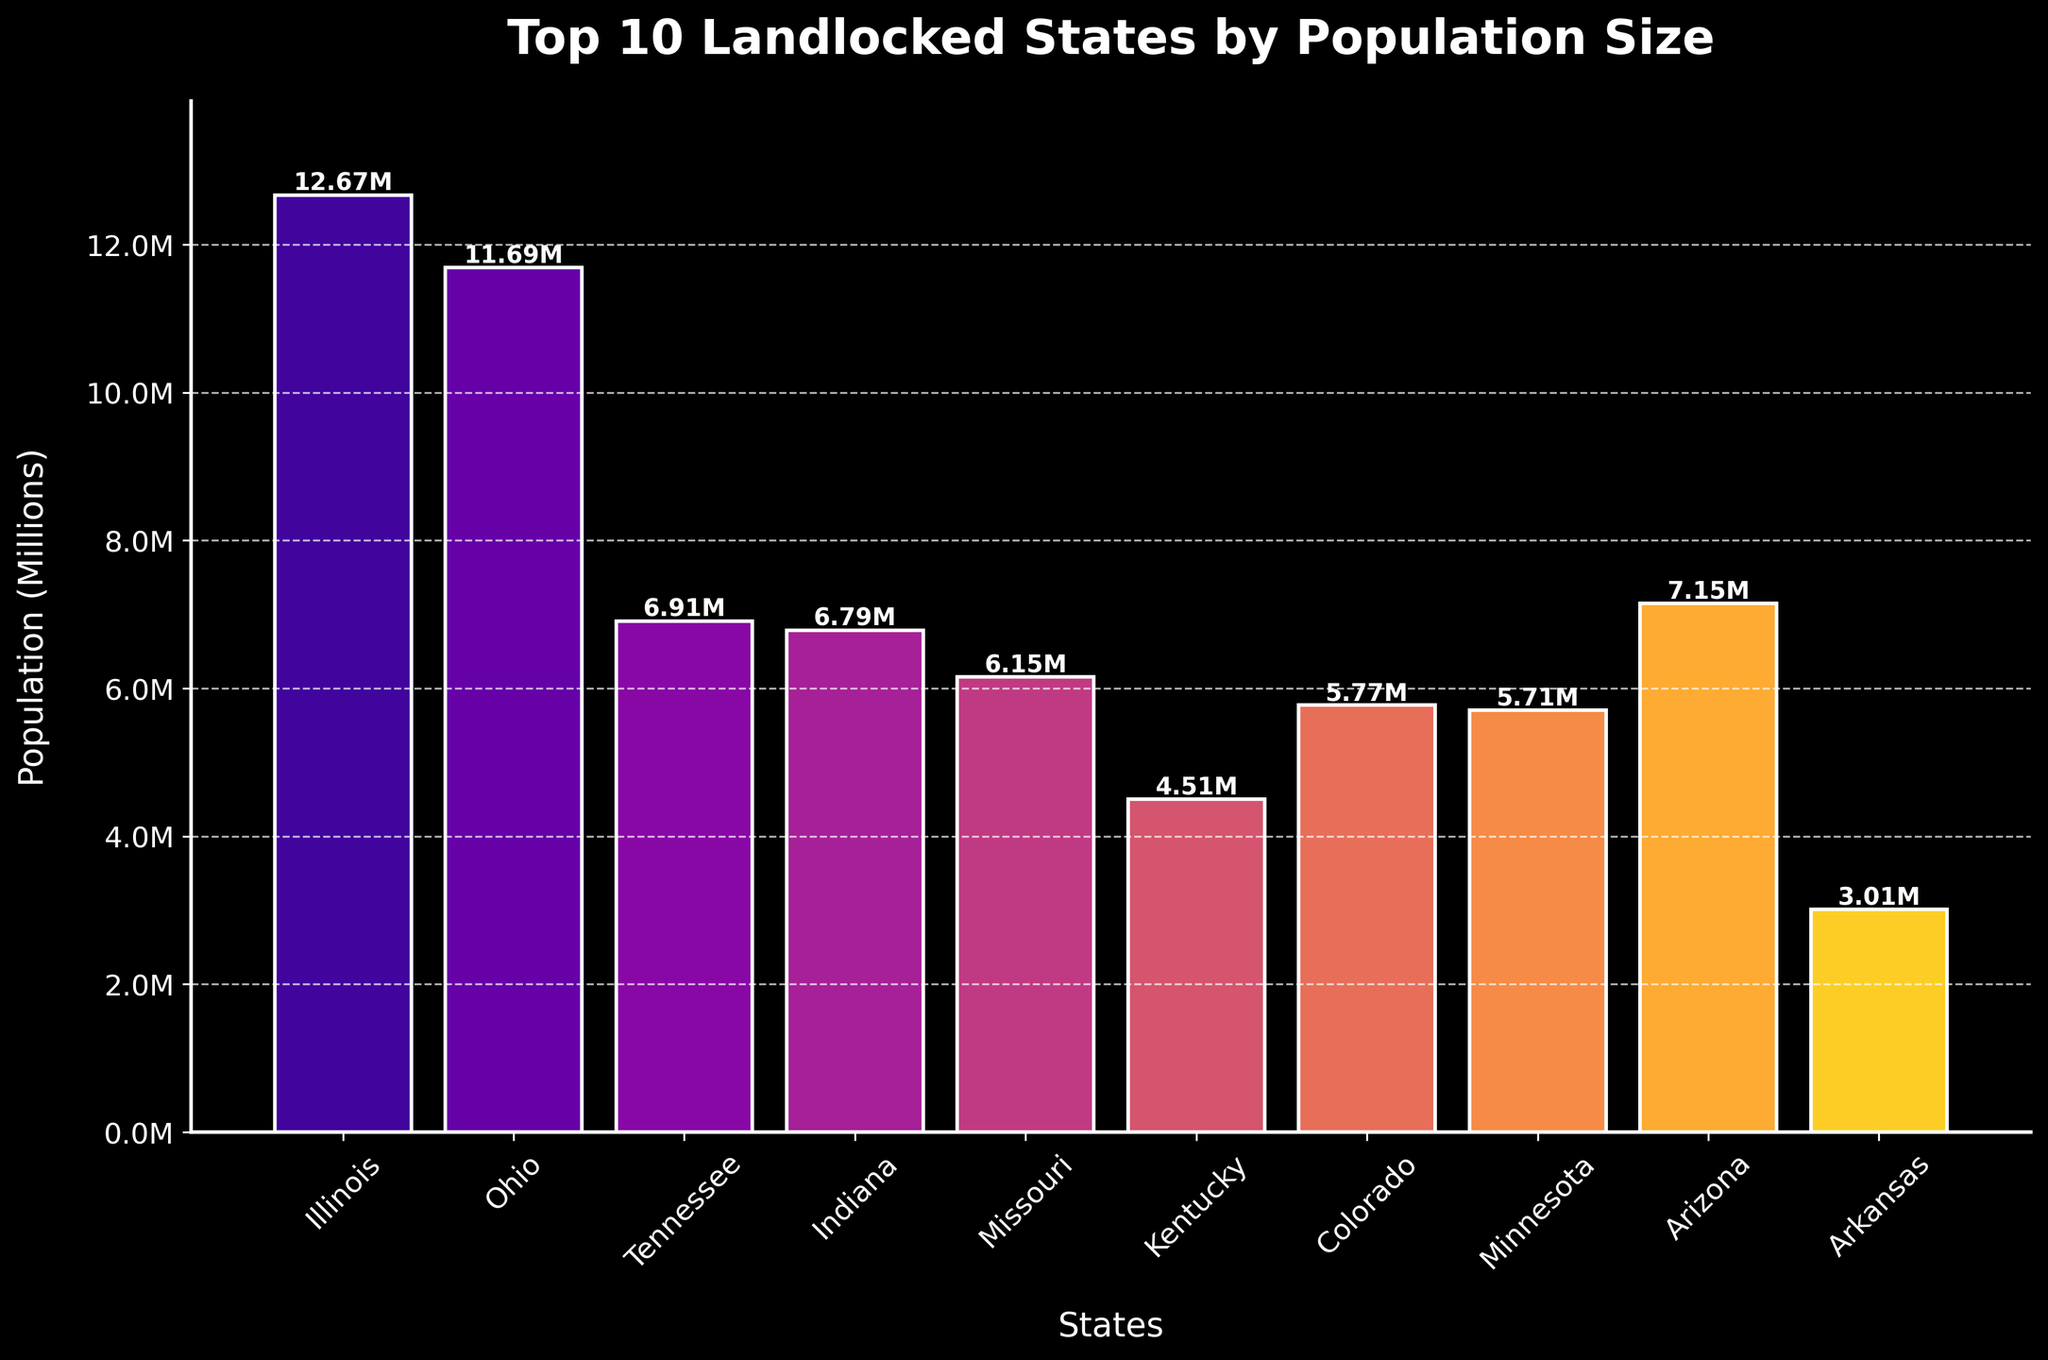Which state has the highest population among the top 10 landlocked states? By looking at the height of the bars, the highest bar corresponds to Illinois, indicating it has the highest population.
Answer: Illinois Which state has the smallest population among the top 10 landlocked states? By observing the lowest bar in terms of height, Arkansas has the smallest population.
Answer: Arkansas What is the combined population of Illinois and Ohio? The Illinois population is 12.67 million, and Ohio's is 11.68 million. Adding them together results in 24.35 million.
Answer: 24.35 million How much larger is Tennessee's population compared to Arkansas'? Tennessee has 6.91 million people, and Arkansas has 3.01 million. Subtracting Arkansas' population from Tennessee's provides the difference: 6.91 - 3.01 = 3.9 million.
Answer: 3.9 million Which state has a population closest to 7 million? By examining the heights of the bars, Arizona has a population closest to 7 million, specifically 7.15 million.
Answer: Arizona Rank the top three states by population in descending order. Observing the heights of the bars, the top three states are Illinois, Ohio, and Arizona.
Answer: Illinois, Ohio, Arizona What is the average population of the top 10 landlocked states? Summing all populations: 12.67 + 11.68 + 6.91 + 6.79 + 6.15 + 4.50 + 5.77 + 5.71 + 7.15 + 3.01 = 70.24 million. Dividing by 10 gives: 70.24 / 10 = 7.02 million.
Answer: 7.02 million Which state has a higher population, Missouri or Colorado? Missouri's population is 6.15 million, while Colorado's is 5.77 million, making Missouri's population higher.
Answer: Missouri What is the population difference between the state with the highest population and the state with the lowest population? Illinois has the highest population at 12.67 million and Arkansas the lowest at 3.01 million. The difference is: 12.67 - 3.01 = 9.66 million.
Answer: 9.66 million How many states have a population greater than 5 million? Counting the bars taller than the 5 million mark shows that Illinois, Ohio, Tennessee, Indiana, Missouri, Colorado, Minnesota, and Arizona meet the criteria, which totals to 8 states.
Answer: 8 